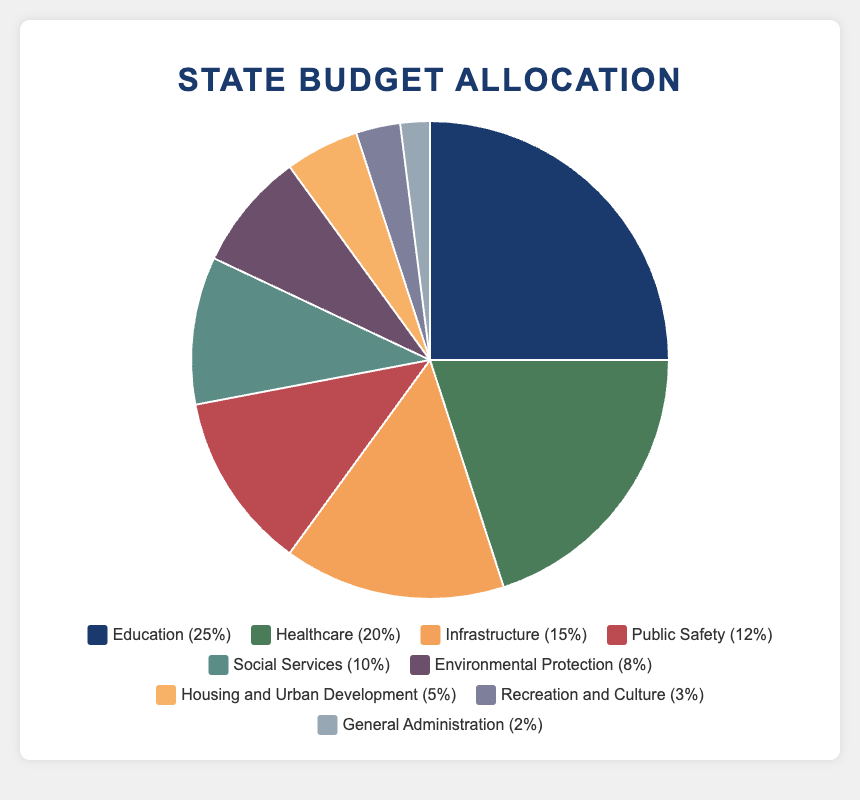Which department received the largest percentage of the budget? Observe the pie chart and find the department with the largest segment, which is "Education" with 25% of the budget allocation.
Answer: Education What is the difference in allocation percentage between Education and Healthcare? Refer to the pie chart to find the allocation percentages for Education (25%) and Healthcare (20%). Subtract Healthcare's percentage from Education's: 25% - 20% = 5%.
Answer: 5% Which two departments have the smallest budget allocation percentages and what are those percentages? In the pie chart, the smallest segments are for General Administration and Recreation and Culture, which have allocations of 2% and 3% respectively.
Answer: General Administration (2%), Recreation and Culture (3%) How much more percentage is allocated to Public Safety compared to Housing and Urban Development? Find the segments for Public Safety (12%) and Housing and Urban Development (5%) in the pie chart. Subtract Housing and Urban Development's percentage from Public Safety's: 12% - 5% = 7%.
Answer: 7% What is the combined allocation percentage for Social Services and Environmental Protection? Locate the segments for Social Services (10%) and Environmental Protection (8%) in the pie chart. Add their percentages together: 10% + 8% = 18%.
Answer: 18% Which department's segment is represented in green and what percentage does it represent? Identify the green-colored segment in the pie chart, which corresponds to Healthcare. The percentage allocated to Healthcare is 20%.
Answer: Healthcare, 20% Which two departments have a combined allocation greater than Healthcare but less than Education? Healthcare's allocation is 20%, Education's is 25%. The combined allocation of Infrastructure (15%) and Public Safety (12%) sums to 27%, which fits the criteria.
Answer: Infrastructure and Public Safety How many departments have an allocation percentage above 10%? Count the segments in the pie chart with percentages above 10%, which are: Education (25%), Healthcare (20%), Infrastructure (15%), and Public Safety (12%). There are 4 such departments.
Answer: 4 departments If you sum the percentages of the five departments with the smallest allocations, what's the total? Identify the smallest allocations: General Administration (2%), Recreation and Culture (3%), Housing and Urban Development (5%), Environmental Protection (8%), and Social Services (10%). Sum these percentages: 2% + 3% + 5% + 8% + 10% = 28%.
Answer: 28% What is the percentage allocation difference between the highest and lowest funded departments? The highest funded department is Education with 25%, and the lowest is General Administration with 2%. Subtract the lowest percentage from the highest: 25% - 2% = 23%.
Answer: 23% 